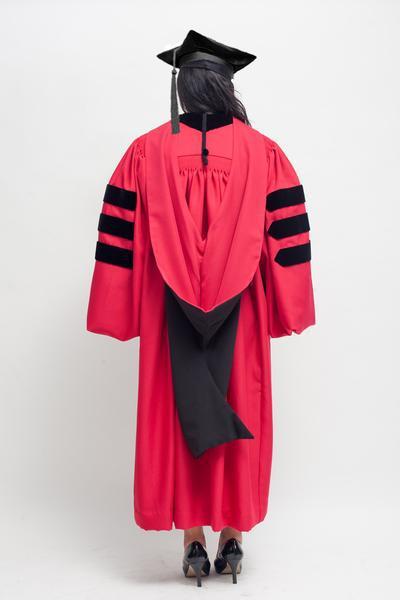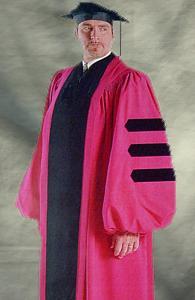The first image is the image on the left, the second image is the image on the right. Assess this claim about the two images: "One image shows a human male with facial hair modeling a tasseled cap and a robe with three stripes per sleeve.". Correct or not? Answer yes or no. Yes. 